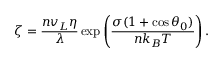<formula> <loc_0><loc_0><loc_500><loc_500>\zeta = \frac { n v _ { L } \eta } { \lambda } \exp \left ( \frac { \sigma ( 1 + \cos \theta _ { 0 } ) } { n k _ { B } T } \right ) .</formula> 